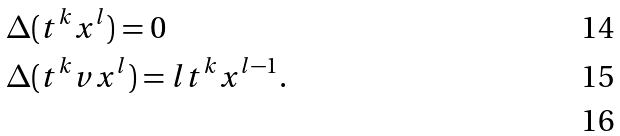Convert formula to latex. <formula><loc_0><loc_0><loc_500><loc_500>& \Delta ( t ^ { k } x ^ { l } ) = 0 \\ & \Delta ( t ^ { k } v x ^ { l } ) = l t ^ { k } x ^ { l - 1 } . \\</formula> 